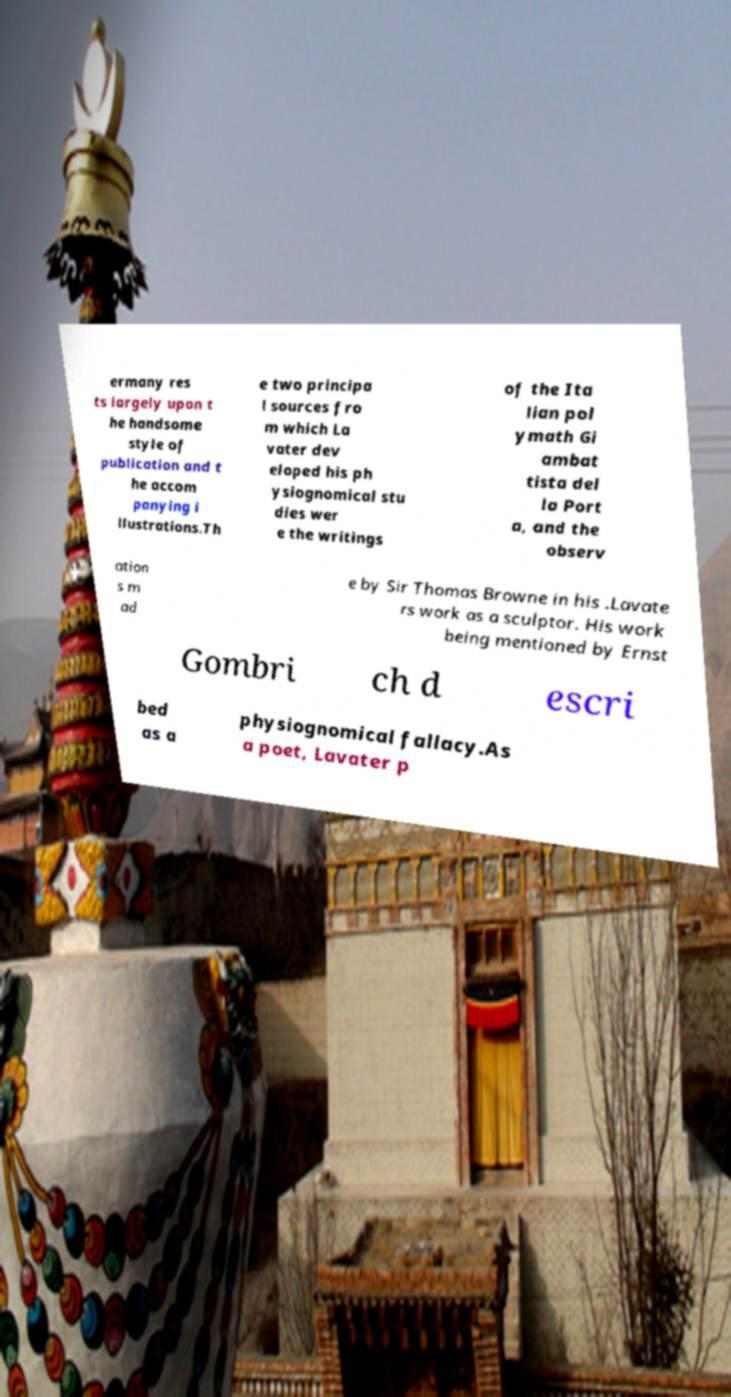Can you read and provide the text displayed in the image?This photo seems to have some interesting text. Can you extract and type it out for me? ermany res ts largely upon t he handsome style of publication and t he accom panying i llustrations.Th e two principa l sources fro m which La vater dev eloped his ph ysiognomical stu dies wer e the writings of the Ita lian pol ymath Gi ambat tista del la Port a, and the observ ation s m ad e by Sir Thomas Browne in his .Lavate rs work as a sculptor. His work being mentioned by Ernst Gombri ch d escri bed as a physiognomical fallacy.As a poet, Lavater p 